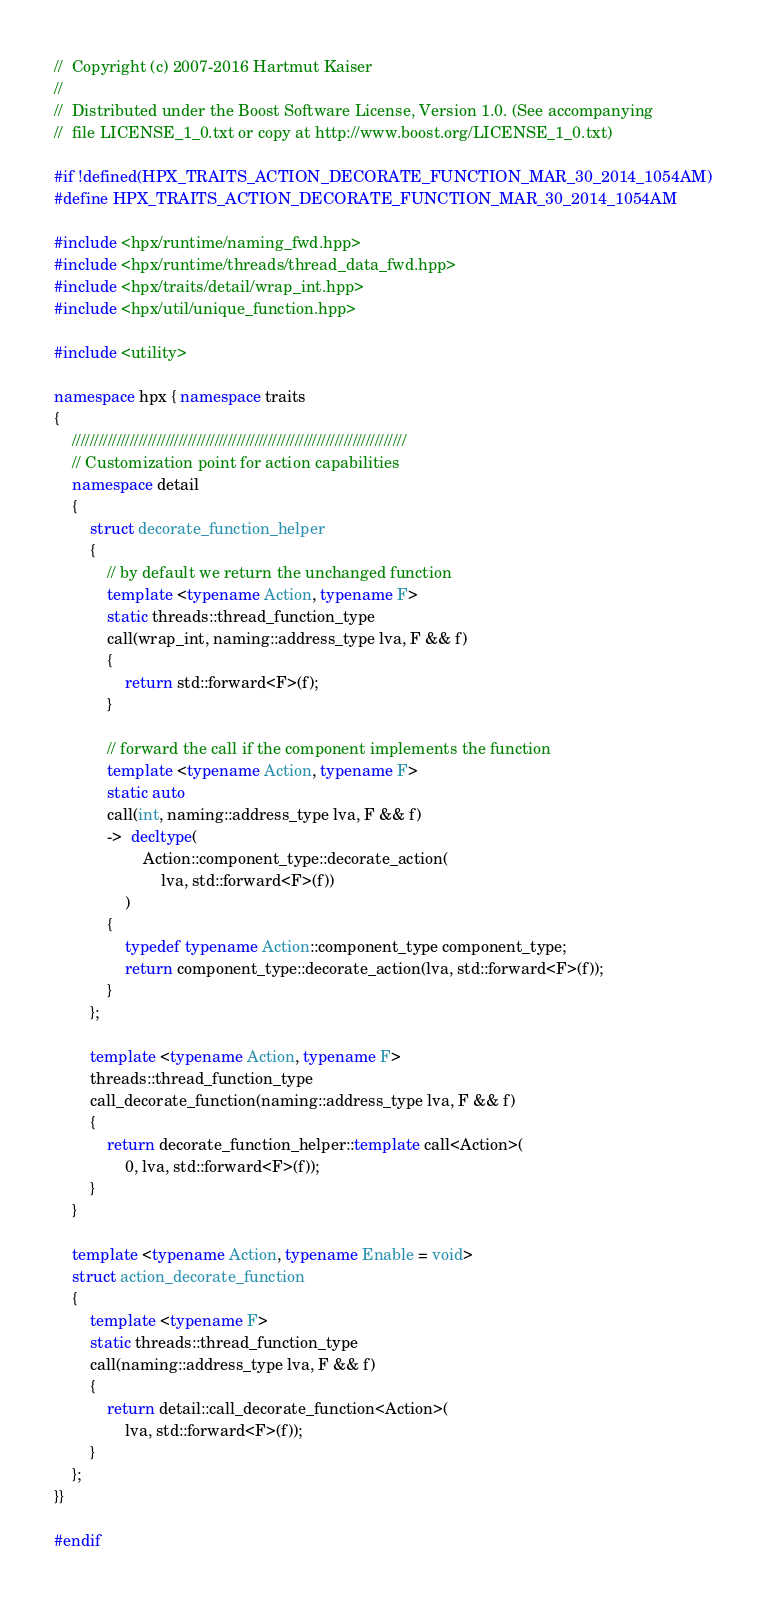Convert code to text. <code><loc_0><loc_0><loc_500><loc_500><_C++_>//  Copyright (c) 2007-2016 Hartmut Kaiser
//
//  Distributed under the Boost Software License, Version 1.0. (See accompanying
//  file LICENSE_1_0.txt or copy at http://www.boost.org/LICENSE_1_0.txt)

#if !defined(HPX_TRAITS_ACTION_DECORATE_FUNCTION_MAR_30_2014_1054AM)
#define HPX_TRAITS_ACTION_DECORATE_FUNCTION_MAR_30_2014_1054AM

#include <hpx/runtime/naming_fwd.hpp>
#include <hpx/runtime/threads/thread_data_fwd.hpp>
#include <hpx/traits/detail/wrap_int.hpp>
#include <hpx/util/unique_function.hpp>

#include <utility>

namespace hpx { namespace traits
{
    ///////////////////////////////////////////////////////////////////////////
    // Customization point for action capabilities
    namespace detail
    {
        struct decorate_function_helper
        {
            // by default we return the unchanged function
            template <typename Action, typename F>
            static threads::thread_function_type
            call(wrap_int, naming::address_type lva, F && f)
            {
                return std::forward<F>(f);
            }

            // forward the call if the component implements the function
            template <typename Action, typename F>
            static auto
            call(int, naming::address_type lva, F && f)
            ->  decltype(
                    Action::component_type::decorate_action(
                        lva, std::forward<F>(f))
                )
            {
                typedef typename Action::component_type component_type;
                return component_type::decorate_action(lva, std::forward<F>(f));
            }
        };

        template <typename Action, typename F>
        threads::thread_function_type
        call_decorate_function(naming::address_type lva, F && f)
        {
            return decorate_function_helper::template call<Action>(
                0, lva, std::forward<F>(f));
        }
    }

    template <typename Action, typename Enable = void>
    struct action_decorate_function
    {
        template <typename F>
        static threads::thread_function_type
        call(naming::address_type lva, F && f)
        {
            return detail::call_decorate_function<Action>(
                lva, std::forward<F>(f));
        }
    };
}}

#endif

</code> 